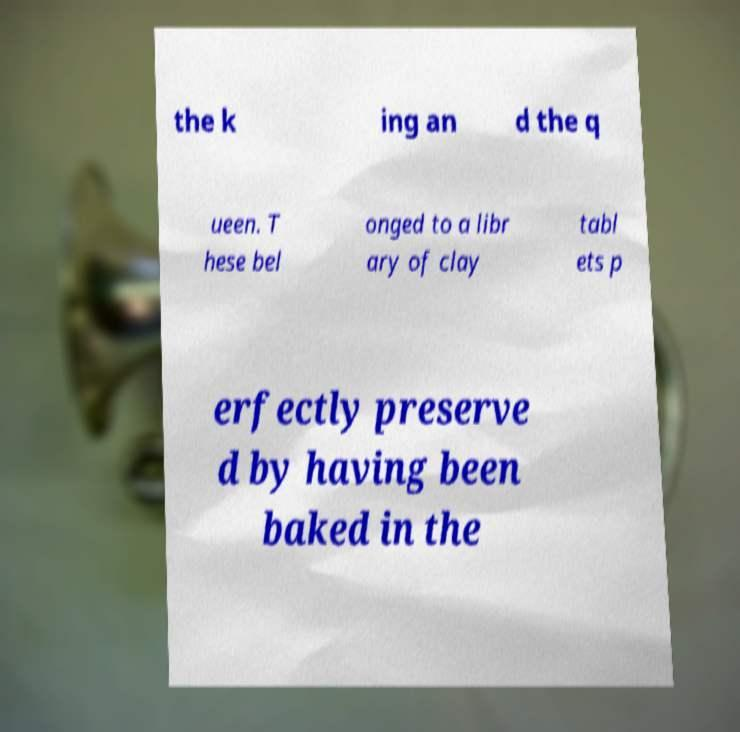Please identify and transcribe the text found in this image. the k ing an d the q ueen. T hese bel onged to a libr ary of clay tabl ets p erfectly preserve d by having been baked in the 